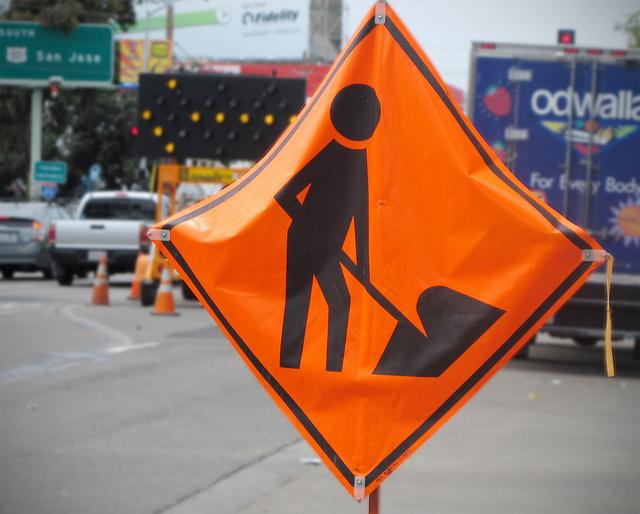What is the figure doing on the orange sign?
Concise answer only. Digging. Which direction is the lighted arrow pointing?
Quick response, please. Left. What direction is the arrow pointing?
Be succinct. Left. 